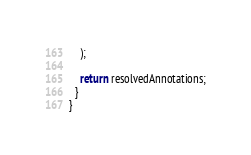Convert code to text. <code><loc_0><loc_0><loc_500><loc_500><_TypeScript_>    );

    return resolvedAnnotations;
  }
}
</code> 